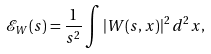<formula> <loc_0><loc_0><loc_500><loc_500>\mathcal { E } _ { W } ( s ) = \frac { 1 } { s ^ { 2 } } \int \left | W ( s , x ) \right | ^ { 2 } d ^ { 2 } x ,</formula> 